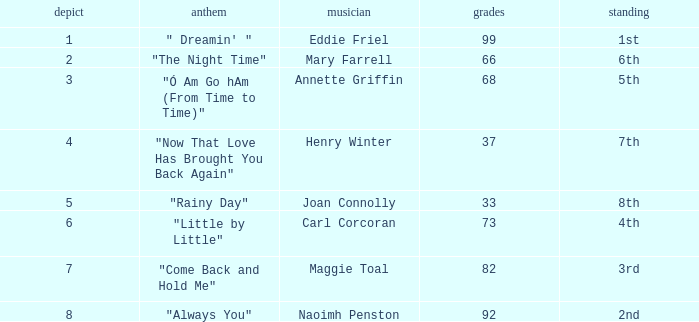Which tune has over 66 points, a tie exceeding 3, and holds the 3rd position in ranking? "Come Back and Hold Me". 